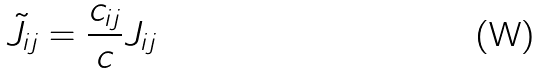<formula> <loc_0><loc_0><loc_500><loc_500>\tilde { J } _ { i j } = \frac { c _ { i j } } { c } J _ { i j }</formula> 